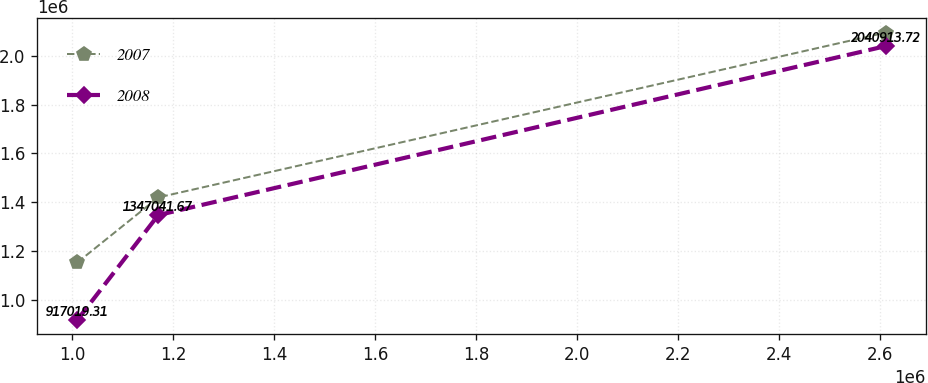<chart> <loc_0><loc_0><loc_500><loc_500><line_chart><ecel><fcel>2007<fcel>2008<nl><fcel>1.01043e+06<fcel>1.15259e+06<fcel>917019<nl><fcel>1.17053e+06<fcel>1.41949e+06<fcel>1.34704e+06<nl><fcel>2.61146e+06<fcel>2.09639e+06<fcel>2.04091e+06<nl></chart> 